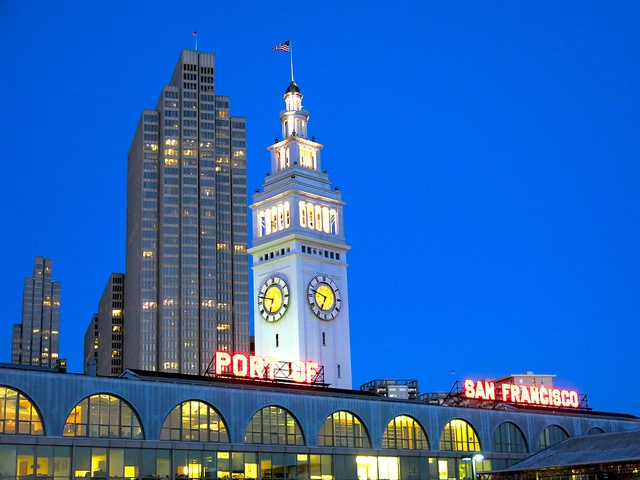Describe the objects in this image and their specific colors. I can see clock in blue, darkgray, gray, and yellow tones and clock in blue, ivory, darkgray, gray, and yellow tones in this image. 